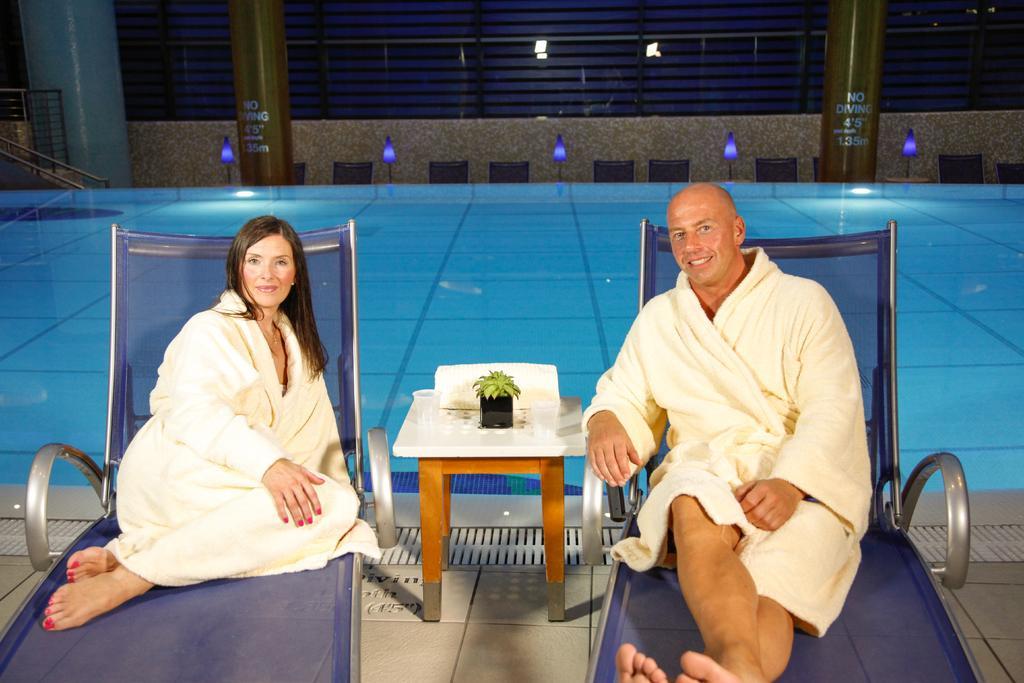Please provide a concise description of this image. In this picture we can see a man and a woman sitting on chairs and smiling and on the floor we can see the table with a houseplant, glasses on it and at the back of them we can see the wall, lights, water, pillars, railings and some objects. 